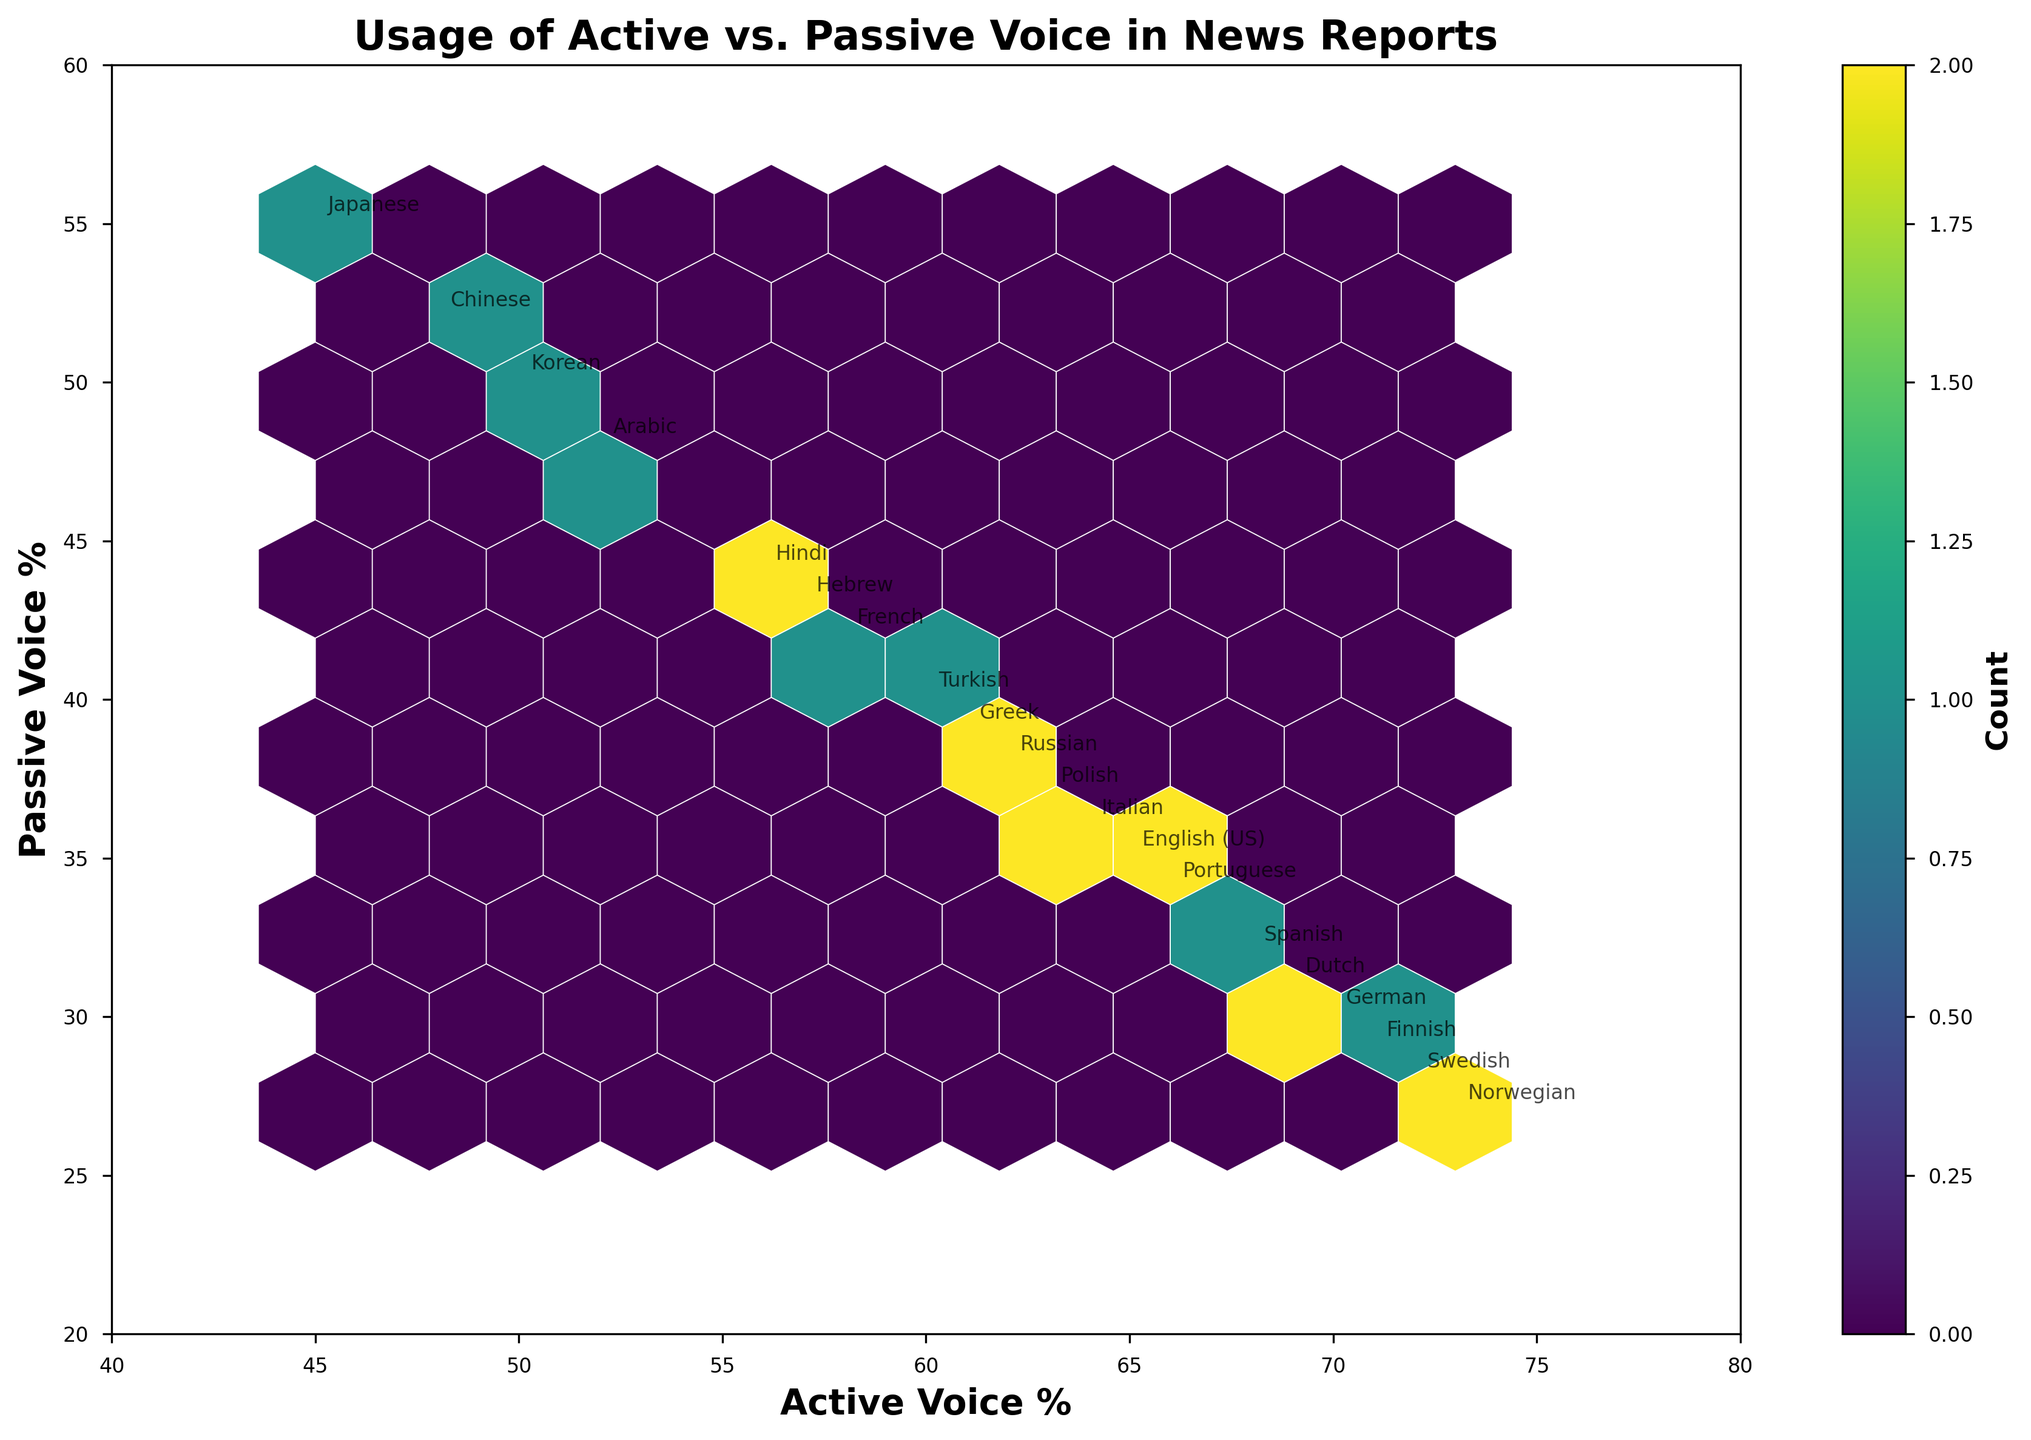what is the range of the x-axis? The x-axis represents "Active Voice %" and ranges from 40 to 80, as indicated by the plot's x-axis limits.
Answer: 40 to 80 which language has the highest percentage of active voice usage? By examining the hexbin plot and the annotations on the points, the language with the highest percentage of active voice usage is Norwegian, which shows an active voice percentage of 73%.
Answer: Norwegian how does the distribution of languages cluster in the hexbin plot? The distribution of languages in the hexbin plot shows clustering mainly between the active voice percentages of 50% to 70% and passive voice percentages of 30% to 50%. This indicates that most languages have a balanced but slightly active voice preference in their news reports.
Answer: Between 50-70% active, 30-50% passive which languages use passive voice more than active voice? By identifying points where the passive voice percentage is higher than the active voice percentage, the languages Japanese and Chinese show more usage of passive voice than active voice.
Answer: Japanese, Chinese what is the title of the plot? The title of the plot is "Usage of Active vs. Passive Voice in News Reports," as clearly indicated at the top of the plot.
Answer: Usage of Active vs. Passive Voice in News Reports how does Swedish compare to German in terms of active and passive voice usage? Swedish has 72% active voice usage and 28% passive voice usage, while German has 70% active voice usage and 30% passive voice usage. Swedish uses slightly more active voice and less passive voice than German.
Answer: Swedish uses 2% more active and 2% less passive than German is there a language with an equal percentage of active and passive voice? Yes, Korean exhibits an equal percentage of active and passive voice usage, both at 50%.
Answer: Korean which languages fall inside the highest density hexbin and what is its significance? By observing the color intensity and density of the hexagonal bins, languages such as English (US), Italian, Portuguese, and Spanish seem to fall inside the highest density region (60-70% active, 30-40% passive), indicating that these languages have a similar balance in voice usage, thus being more predominant among the dataset.
Answer: English (US), Italian, Portuguese, Spanish which language has a passive voice percentage close to 40% but an active voice percentage differing from 60% the most? Turkish has a passive voice percentage of 40% and an active voice percentage of 60%. Checking other languages with passive voice close to 40%, French has an active voice percentage of 58% which differs the most by being 2% below 60%.
Answer: French 